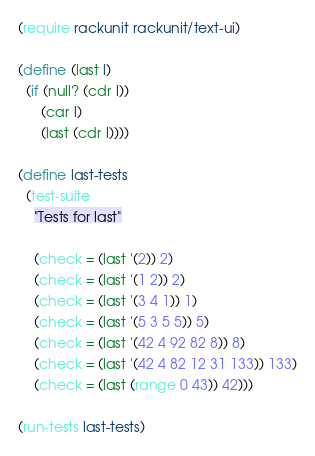<code> <loc_0><loc_0><loc_500><loc_500><_Scheme_>(require rackunit rackunit/text-ui)

(define (last l)
  (if (null? (cdr l))
      (car l)
      (last (cdr l))))

(define last-tests
  (test-suite
    "Tests for last"

    (check = (last '(2)) 2)
    (check = (last '(1 2)) 2)
    (check = (last '(3 4 1)) 1)
    (check = (last '(5 3 5 5)) 5)
    (check = (last '(42 4 92 82 8)) 8)
    (check = (last '(42 4 82 12 31 133)) 133)
    (check = (last (range 0 43)) 42)))

(run-tests last-tests)
</code> 